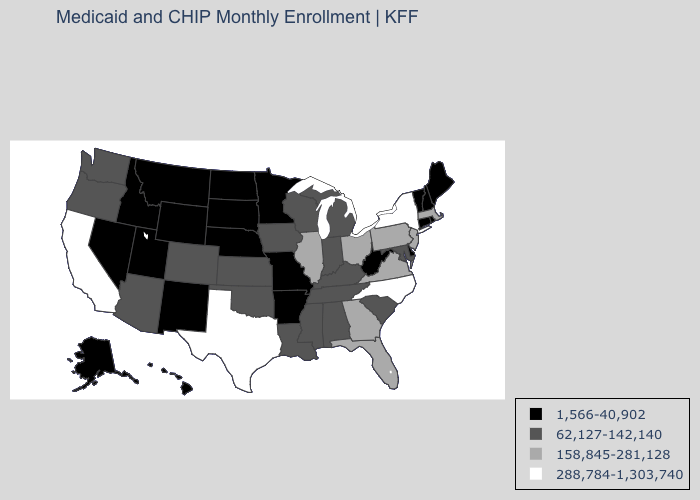Name the states that have a value in the range 288,784-1,303,740?
Answer briefly. California, New York, North Carolina, Texas. What is the value of West Virginia?
Quick response, please. 1,566-40,902. Name the states that have a value in the range 158,845-281,128?
Keep it brief. Florida, Georgia, Illinois, Massachusetts, New Jersey, Ohio, Pennsylvania, Virginia. What is the highest value in the West ?
Keep it brief. 288,784-1,303,740. Does the first symbol in the legend represent the smallest category?
Be succinct. Yes. Which states hav the highest value in the MidWest?
Quick response, please. Illinois, Ohio. Among the states that border Vermont , which have the highest value?
Write a very short answer. New York. What is the highest value in the USA?
Answer briefly. 288,784-1,303,740. Name the states that have a value in the range 62,127-142,140?
Quick response, please. Alabama, Arizona, Colorado, Indiana, Iowa, Kansas, Kentucky, Louisiana, Maryland, Michigan, Mississippi, Oklahoma, Oregon, South Carolina, Tennessee, Washington, Wisconsin. Among the states that border Tennessee , which have the lowest value?
Short answer required. Arkansas, Missouri. What is the value of Montana?
Short answer required. 1,566-40,902. What is the lowest value in states that border Wisconsin?
Write a very short answer. 1,566-40,902. Does Connecticut have the same value as Illinois?
Short answer required. No. What is the highest value in states that border Iowa?
Give a very brief answer. 158,845-281,128. What is the value of Rhode Island?
Short answer required. 1,566-40,902. 